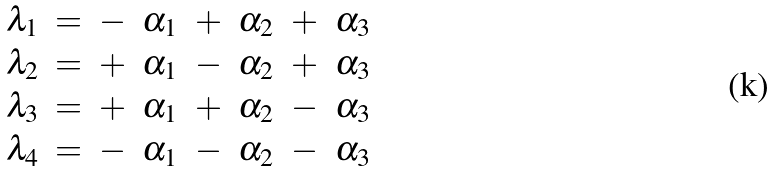Convert formula to latex. <formula><loc_0><loc_0><loc_500><loc_500>\begin{array} { l l l l l l l l } \lambda _ { 1 } & = & - & \alpha _ { 1 } & + & \alpha _ { 2 } & + & \alpha _ { 3 } \\ \lambda _ { 2 } & = & + & \alpha _ { 1 } & - & \alpha _ { 2 } & + & \alpha _ { 3 } \\ \lambda _ { 3 } & = & + & \alpha _ { 1 } & + & \alpha _ { 2 } & - & \alpha _ { 3 } \\ \lambda _ { 4 } & = & - & \alpha _ { 1 } & - & \alpha _ { 2 } & - & \alpha _ { 3 } \end{array}</formula> 